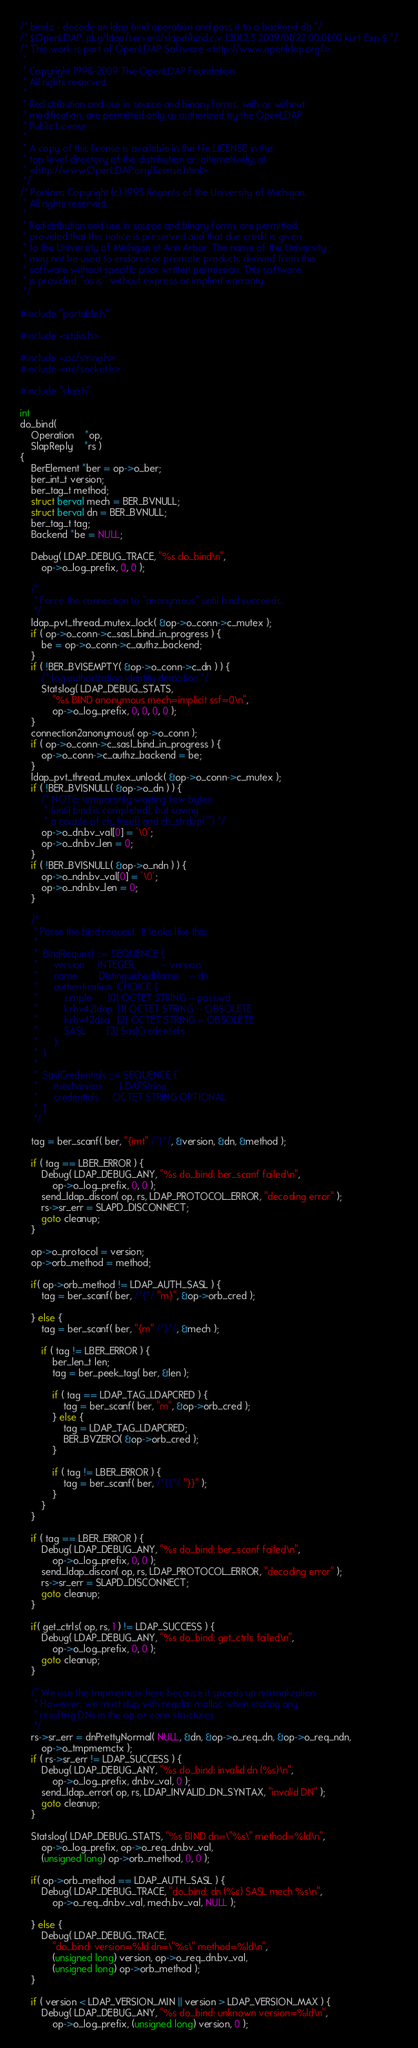<code> <loc_0><loc_0><loc_500><loc_500><_C_>/* bind.c - decode an ldap bind operation and pass it to a backend db */
/* $OpenLDAP: pkg/ldap/servers/slapd/bind.c,v 1.201.2.5 2009/01/22 00:01:00 kurt Exp $ */
/* This work is part of OpenLDAP Software <http://www.openldap.org/>.
 *
 * Copyright 1998-2009 The OpenLDAP Foundation.
 * All rights reserved.
 *
 * Redistribution and use in source and binary forms, with or without
 * modification, are permitted only as authorized by the OpenLDAP
 * Public License.
 *
 * A copy of this license is available in the file LICENSE in the
 * top-level directory of the distribution or, alternatively, at
 * <http://www.OpenLDAP.org/license.html>.
 */
/* Portions Copyright (c) 1995 Regents of the University of Michigan.
 * All rights reserved.
 *
 * Redistribution and use in source and binary forms are permitted
 * provided that this notice is preserved and that due credit is given
 * to the University of Michigan at Ann Arbor. The name of the University
 * may not be used to endorse or promote products derived from this
 * software without specific prior written permission. This software
 * is provided ``as is'' without express or implied warranty.
 */

#include "portable.h"

#include <stdio.h>

#include <ac/string.h>
#include <ac/socket.h>

#include "slap.h"

int
do_bind(
    Operation	*op,
    SlapReply	*rs )
{
	BerElement *ber = op->o_ber;
	ber_int_t version;
	ber_tag_t method;
	struct berval mech = BER_BVNULL;
	struct berval dn = BER_BVNULL;
	ber_tag_t tag;
	Backend *be = NULL;

	Debug( LDAP_DEBUG_TRACE, "%s do_bind\n",
		op->o_log_prefix, 0, 0 );

	/*
	 * Force the connection to "anonymous" until bind succeeds.
	 */
	ldap_pvt_thread_mutex_lock( &op->o_conn->c_mutex );
	if ( op->o_conn->c_sasl_bind_in_progress ) {
		be = op->o_conn->c_authz_backend;
	}
	if ( !BER_BVISEMPTY( &op->o_conn->c_dn ) ) {
		/* log authorization identity demotion */
		Statslog( LDAP_DEBUG_STATS,
			"%s BIND anonymous mech=implicit ssf=0\n",
			op->o_log_prefix, 0, 0, 0, 0 );
	}
	connection2anonymous( op->o_conn );
	if ( op->o_conn->c_sasl_bind_in_progress ) {
		op->o_conn->c_authz_backend = be;
	}
	ldap_pvt_thread_mutex_unlock( &op->o_conn->c_mutex );
	if ( !BER_BVISNULL( &op->o_dn ) ) {
		/* NOTE: temporarily wasting few bytes
		 * (until bind is completed), but saving
		 * a couple of ch_free() and ch_strdup("") */ 
		op->o_dn.bv_val[0] = '\0';
		op->o_dn.bv_len = 0;
	}
	if ( !BER_BVISNULL( &op->o_ndn ) ) {
		op->o_ndn.bv_val[0] = '\0';
		op->o_ndn.bv_len = 0;
	}

	/*
	 * Parse the bind request.  It looks like this:
	 *
	 *	BindRequest ::= SEQUENCE {
	 *		version		INTEGER,		 -- version
	 *		name		DistinguishedName,	 -- dn
	 *		authentication	CHOICE {
	 *			simple		[0] OCTET STRING -- passwd
	 *			krbv42ldap	[1] OCTET STRING -- OBSOLETE
	 *			krbv42dsa	[2] OCTET STRING -- OBSOLETE
	 *			SASL		[3] SaslCredentials
	 *		}
	 *	}
	 *
	 *	SaslCredentials ::= SEQUENCE {
	 *		mechanism	    LDAPString,
	 *		credentials	    OCTET STRING OPTIONAL
	 *	}
	 */

	tag = ber_scanf( ber, "{imt" /*}*/, &version, &dn, &method );

	if ( tag == LBER_ERROR ) {
		Debug( LDAP_DEBUG_ANY, "%s do_bind: ber_scanf failed\n",
			op->o_log_prefix, 0, 0 );
		send_ldap_discon( op, rs, LDAP_PROTOCOL_ERROR, "decoding error" );
		rs->sr_err = SLAPD_DISCONNECT;
		goto cleanup;
	}

	op->o_protocol = version;
	op->orb_method = method;

	if( op->orb_method != LDAP_AUTH_SASL ) {
		tag = ber_scanf( ber, /*{*/ "m}", &op->orb_cred );

	} else {
		tag = ber_scanf( ber, "{m" /*}*/, &mech );

		if ( tag != LBER_ERROR ) {
			ber_len_t len;
			tag = ber_peek_tag( ber, &len );

			if ( tag == LDAP_TAG_LDAPCRED ) { 
				tag = ber_scanf( ber, "m", &op->orb_cred );
			} else {
				tag = LDAP_TAG_LDAPCRED;
				BER_BVZERO( &op->orb_cred );
			}

			if ( tag != LBER_ERROR ) {
				tag = ber_scanf( ber, /*{{*/ "}}" );
			}
		}
	}

	if ( tag == LBER_ERROR ) {
		Debug( LDAP_DEBUG_ANY, "%s do_bind: ber_scanf failed\n",
			op->o_log_prefix, 0, 0 );
		send_ldap_discon( op, rs, LDAP_PROTOCOL_ERROR, "decoding error" );
		rs->sr_err = SLAPD_DISCONNECT;
		goto cleanup;
	}

	if( get_ctrls( op, rs, 1 ) != LDAP_SUCCESS ) {
		Debug( LDAP_DEBUG_ANY, "%s do_bind: get_ctrls failed\n",
			op->o_log_prefix, 0, 0 );
		goto cleanup;
	} 

	/* We use the tmpmemctx here because it speeds up normalization.
	 * However, we must dup with regular malloc when storing any
	 * resulting DNs in the op or conn structures.
	 */
	rs->sr_err = dnPrettyNormal( NULL, &dn, &op->o_req_dn, &op->o_req_ndn,
		op->o_tmpmemctx );
	if ( rs->sr_err != LDAP_SUCCESS ) {
		Debug( LDAP_DEBUG_ANY, "%s do_bind: invalid dn (%s)\n",
			op->o_log_prefix, dn.bv_val, 0 );
		send_ldap_error( op, rs, LDAP_INVALID_DN_SYNTAX, "invalid DN" );
		goto cleanup;
	}

	Statslog( LDAP_DEBUG_STATS, "%s BIND dn=\"%s\" method=%ld\n",
	    op->o_log_prefix, op->o_req_dn.bv_val,
		(unsigned long) op->orb_method, 0, 0 );

	if( op->orb_method == LDAP_AUTH_SASL ) {
		Debug( LDAP_DEBUG_TRACE, "do_bind: dn (%s) SASL mech %s\n",
			op->o_req_dn.bv_val, mech.bv_val, NULL );

	} else {
		Debug( LDAP_DEBUG_TRACE,
			"do_bind: version=%ld dn=\"%s\" method=%ld\n",
			(unsigned long) version, op->o_req_dn.bv_val,
			(unsigned long) op->orb_method );
	}

	if ( version < LDAP_VERSION_MIN || version > LDAP_VERSION_MAX ) {
		Debug( LDAP_DEBUG_ANY, "%s do_bind: unknown version=%ld\n",
			op->o_log_prefix, (unsigned long) version, 0 );</code> 